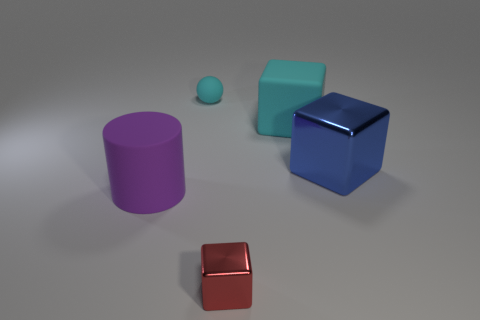Are there any objects behind the large blue block?
Offer a very short reply. Yes. Do the red block and the cyan cube have the same size?
Your response must be concise. No. What number of blocks are made of the same material as the blue thing?
Your answer should be very brief. 1. There is a metal block behind the large object that is on the left side of the cyan sphere; what size is it?
Keep it short and to the point. Large. The thing that is in front of the blue shiny cube and right of the small matte sphere is what color?
Your response must be concise. Red. Does the blue metal object have the same shape as the tiny rubber thing?
Provide a succinct answer. No. What is the size of the rubber thing that is the same color as the sphere?
Ensure brevity in your answer.  Large. There is a cyan rubber thing behind the large cube to the left of the big blue thing; what shape is it?
Ensure brevity in your answer.  Sphere. There is a red object; is it the same shape as the large matte thing behind the blue object?
Your answer should be very brief. Yes. There is a rubber thing that is the same size as the purple cylinder; what color is it?
Offer a terse response. Cyan. 